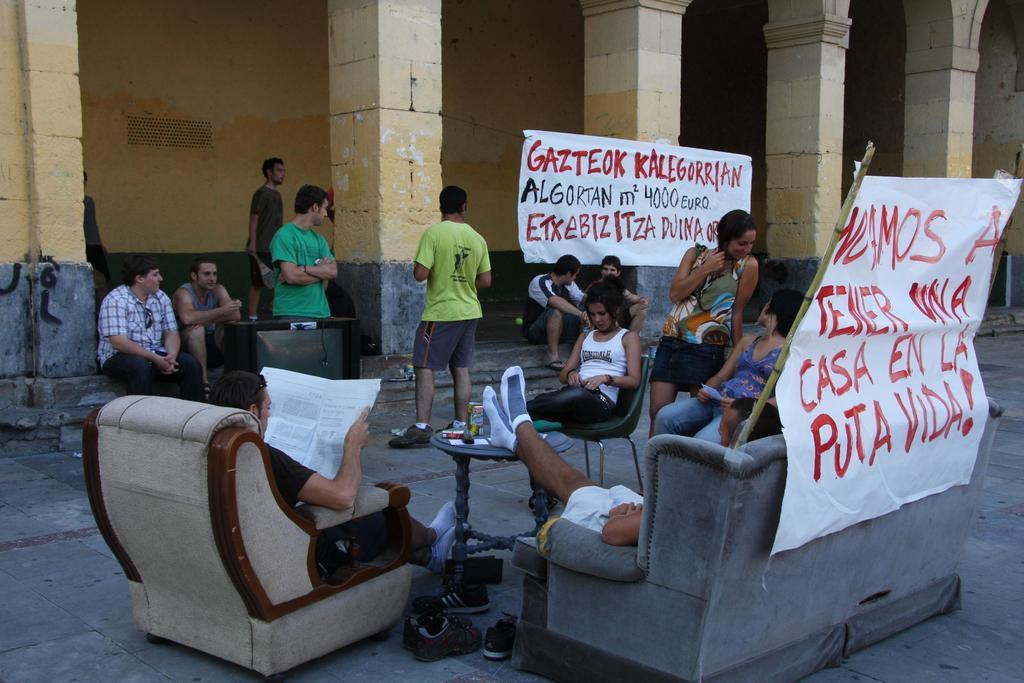In one or two sentences, can you explain what this image depicts? There is a group of people. They are sitting on a chairs and sofa. Some persons are standing. On the left side we have a person. He is reading a paper. There is a table. There is a bottle ,paper on a table. We can see in background pillar,wall and banner. 